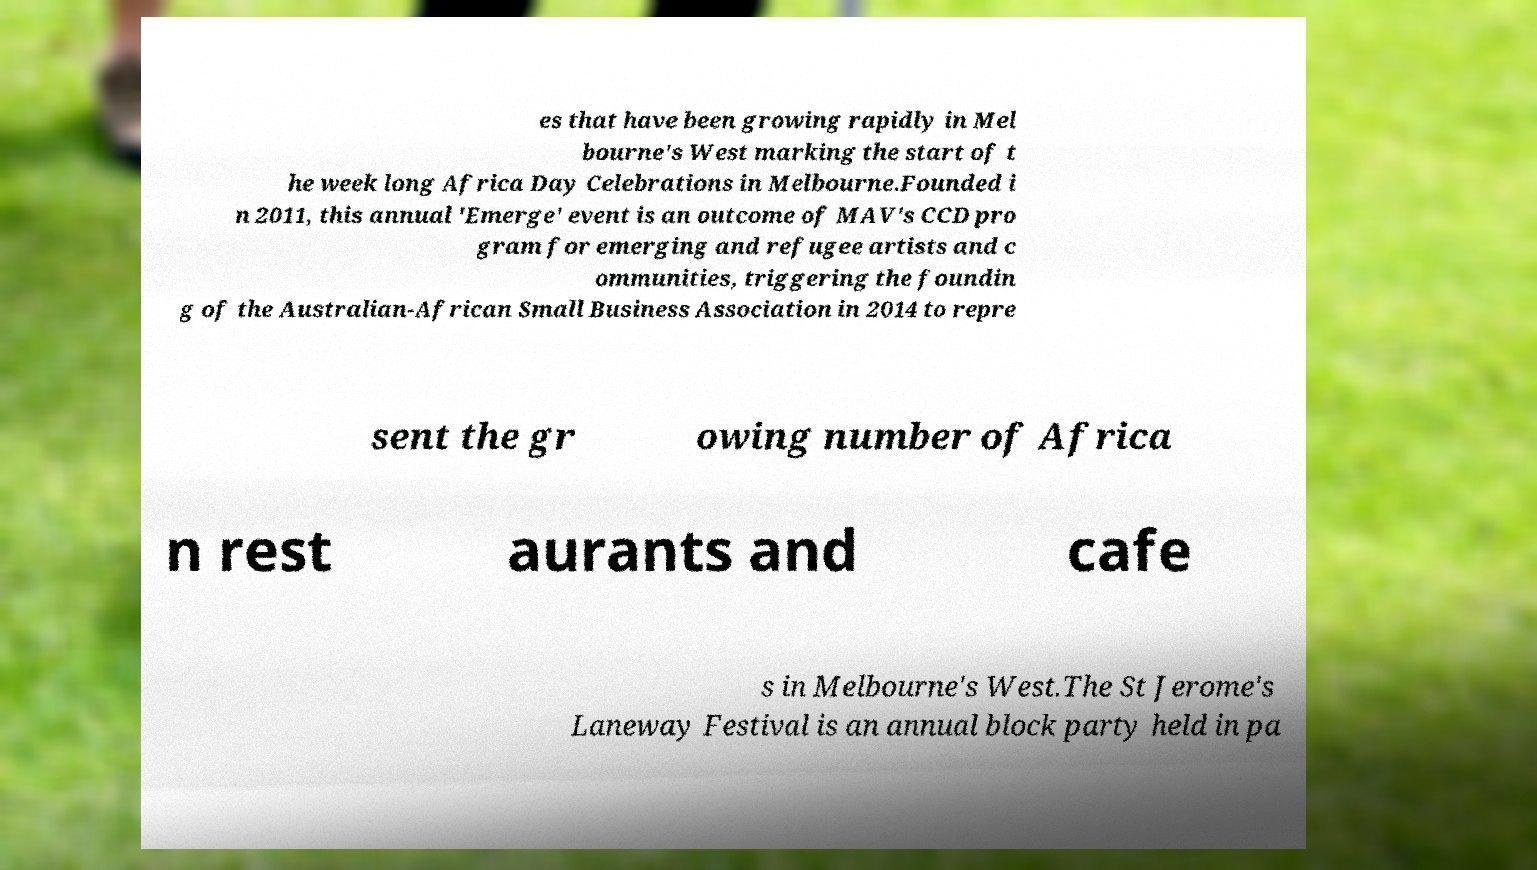There's text embedded in this image that I need extracted. Can you transcribe it verbatim? es that have been growing rapidly in Mel bourne's West marking the start of t he week long Africa Day Celebrations in Melbourne.Founded i n 2011, this annual 'Emerge' event is an outcome of MAV's CCD pro gram for emerging and refugee artists and c ommunities, triggering the foundin g of the Australian-African Small Business Association in 2014 to repre sent the gr owing number of Africa n rest aurants and cafe s in Melbourne's West.The St Jerome's Laneway Festival is an annual block party held in pa 